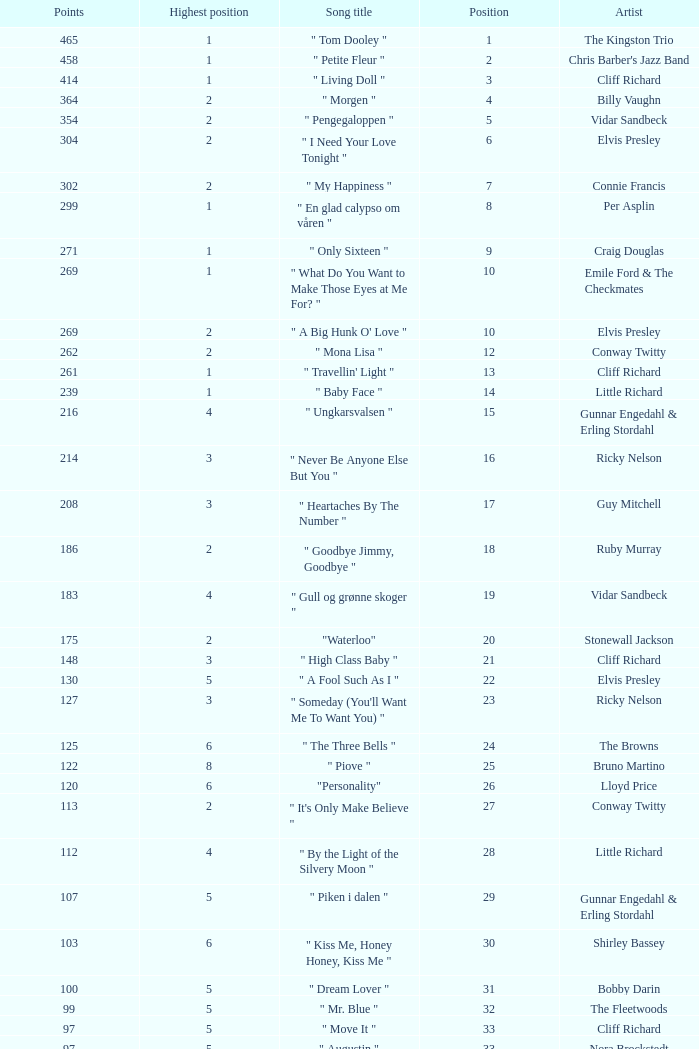What is the nme of the song performed by billy vaughn? " Morgen ". 